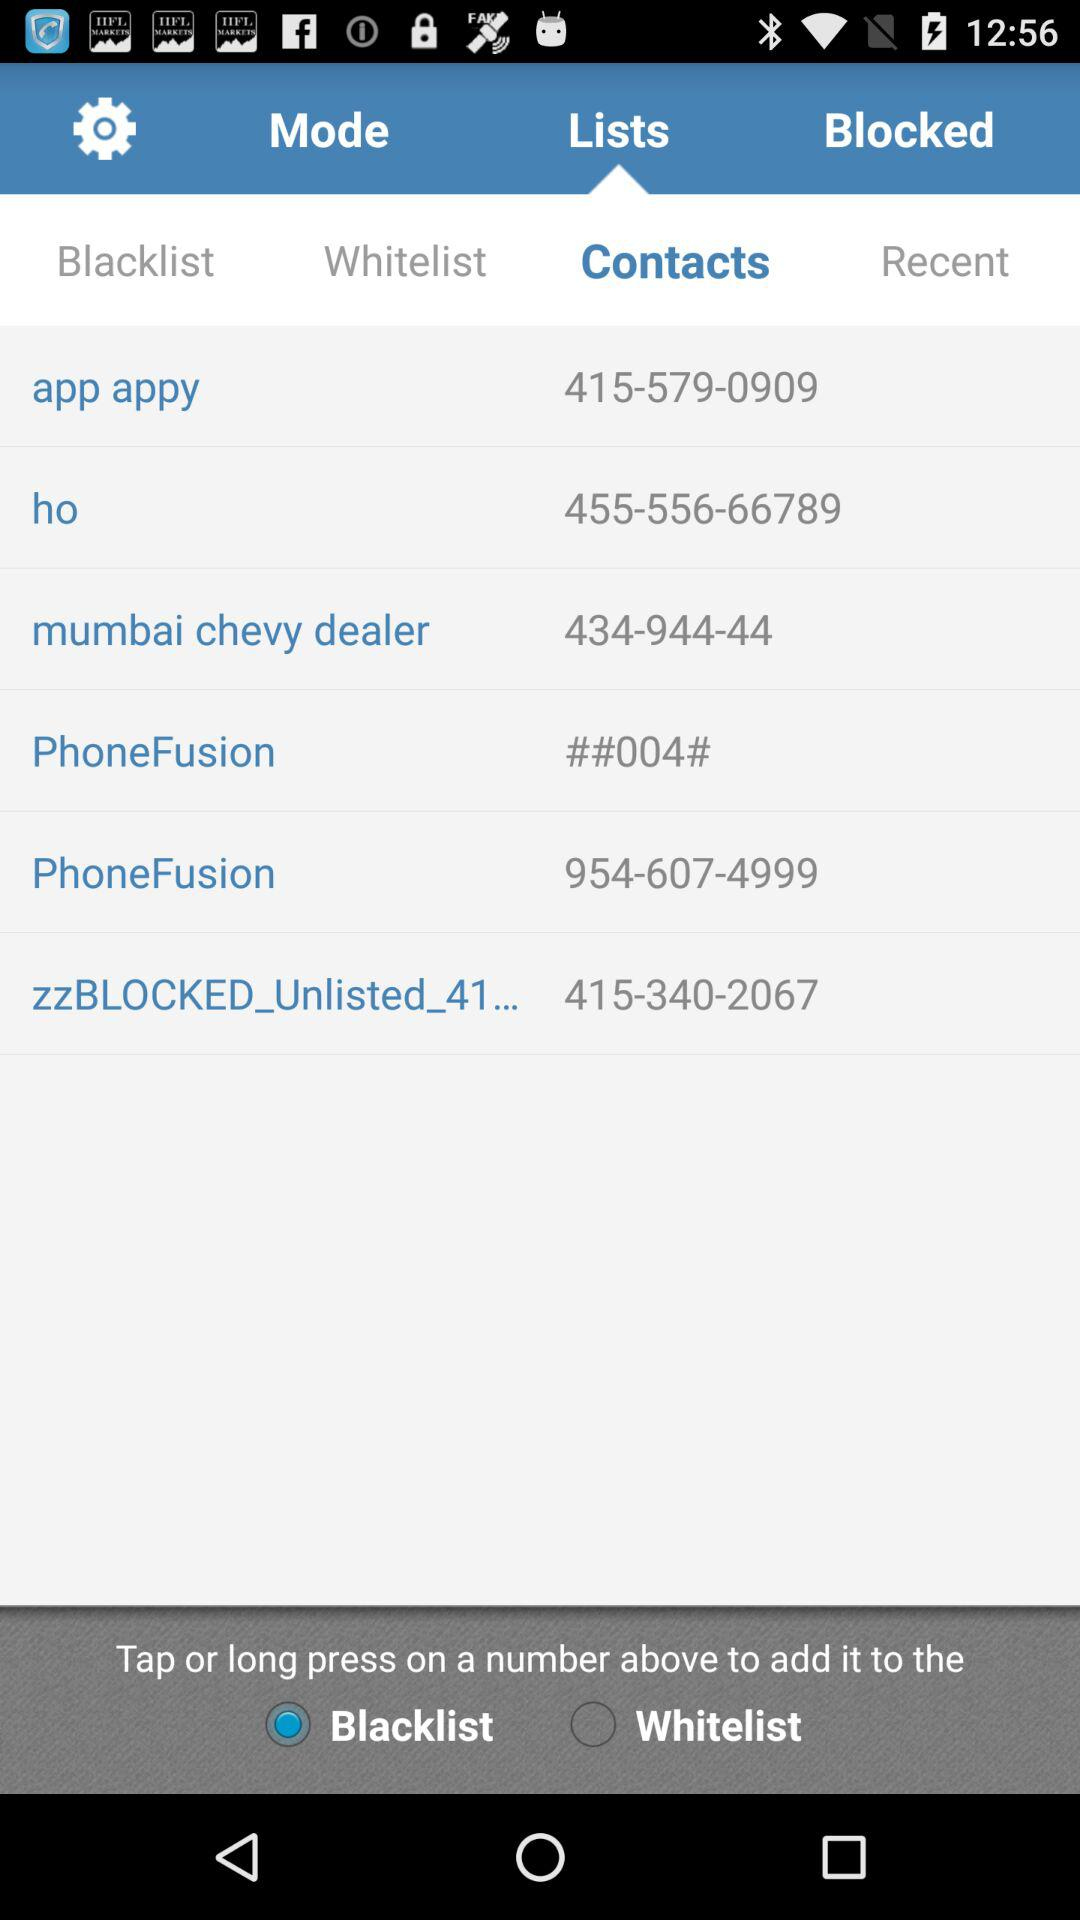What is the contact number of "zzBLOCKED_Unlisted_41..."? The contact number is 415-340-2067. 